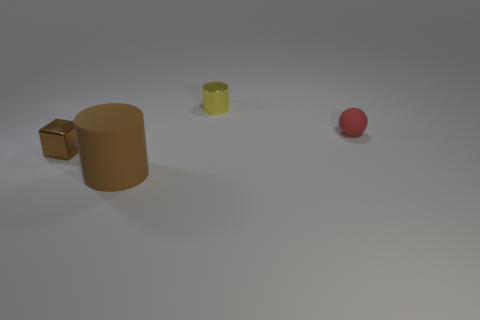Subtract all green cylinders. Subtract all green balls. How many cylinders are left? 2 Add 1 small yellow shiny cylinders. How many objects exist? 5 Subtract all blocks. How many objects are left? 3 Add 1 big green things. How many big green things exist? 1 Subtract 0 gray cylinders. How many objects are left? 4 Subtract all large rubber cylinders. Subtract all large blocks. How many objects are left? 3 Add 4 tiny metal things. How many tiny metal things are left? 6 